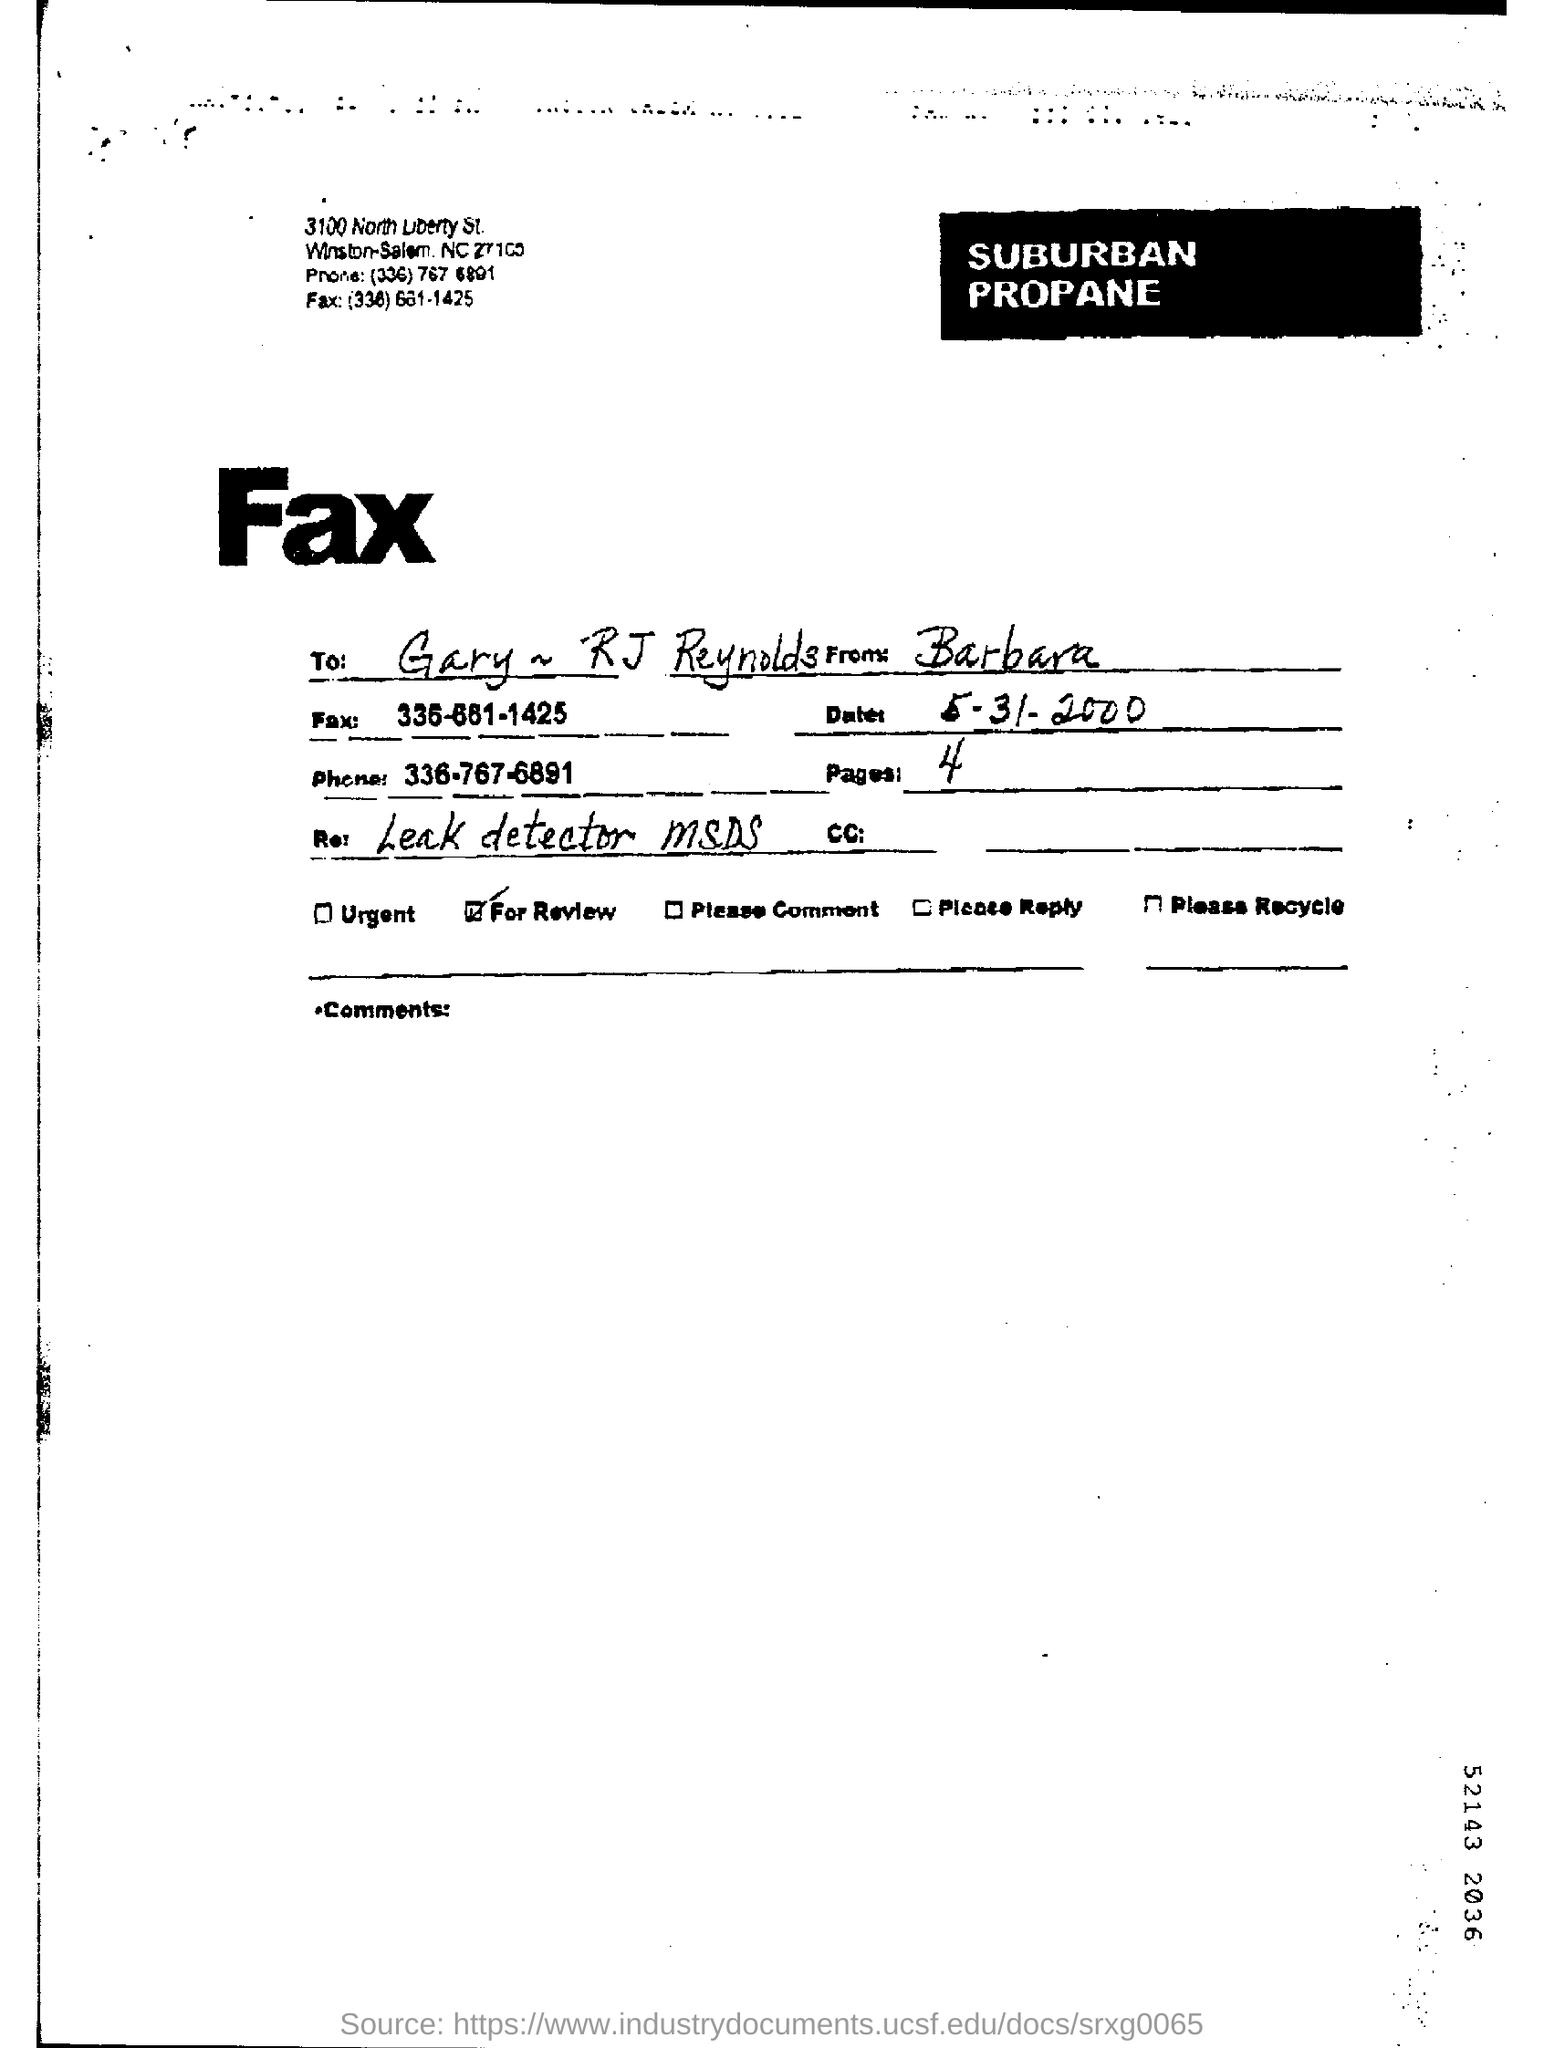What is the date mentioned in the fax ?
Make the answer very short. 5-31-2000. How many pages are there in the fax ?
Your answer should be very brief. 4. What is the phone number mentioned in the fax ?
Ensure brevity in your answer.  336-767-6891. 